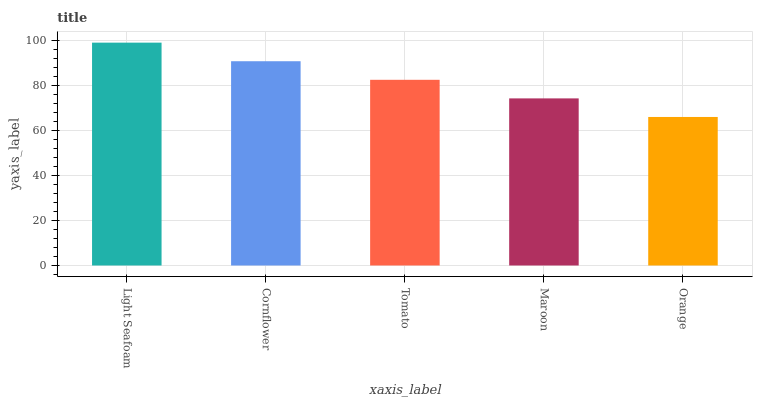Is Orange the minimum?
Answer yes or no. Yes. Is Light Seafoam the maximum?
Answer yes or no. Yes. Is Cornflower the minimum?
Answer yes or no. No. Is Cornflower the maximum?
Answer yes or no. No. Is Light Seafoam greater than Cornflower?
Answer yes or no. Yes. Is Cornflower less than Light Seafoam?
Answer yes or no. Yes. Is Cornflower greater than Light Seafoam?
Answer yes or no. No. Is Light Seafoam less than Cornflower?
Answer yes or no. No. Is Tomato the high median?
Answer yes or no. Yes. Is Tomato the low median?
Answer yes or no. Yes. Is Cornflower the high median?
Answer yes or no. No. Is Cornflower the low median?
Answer yes or no. No. 